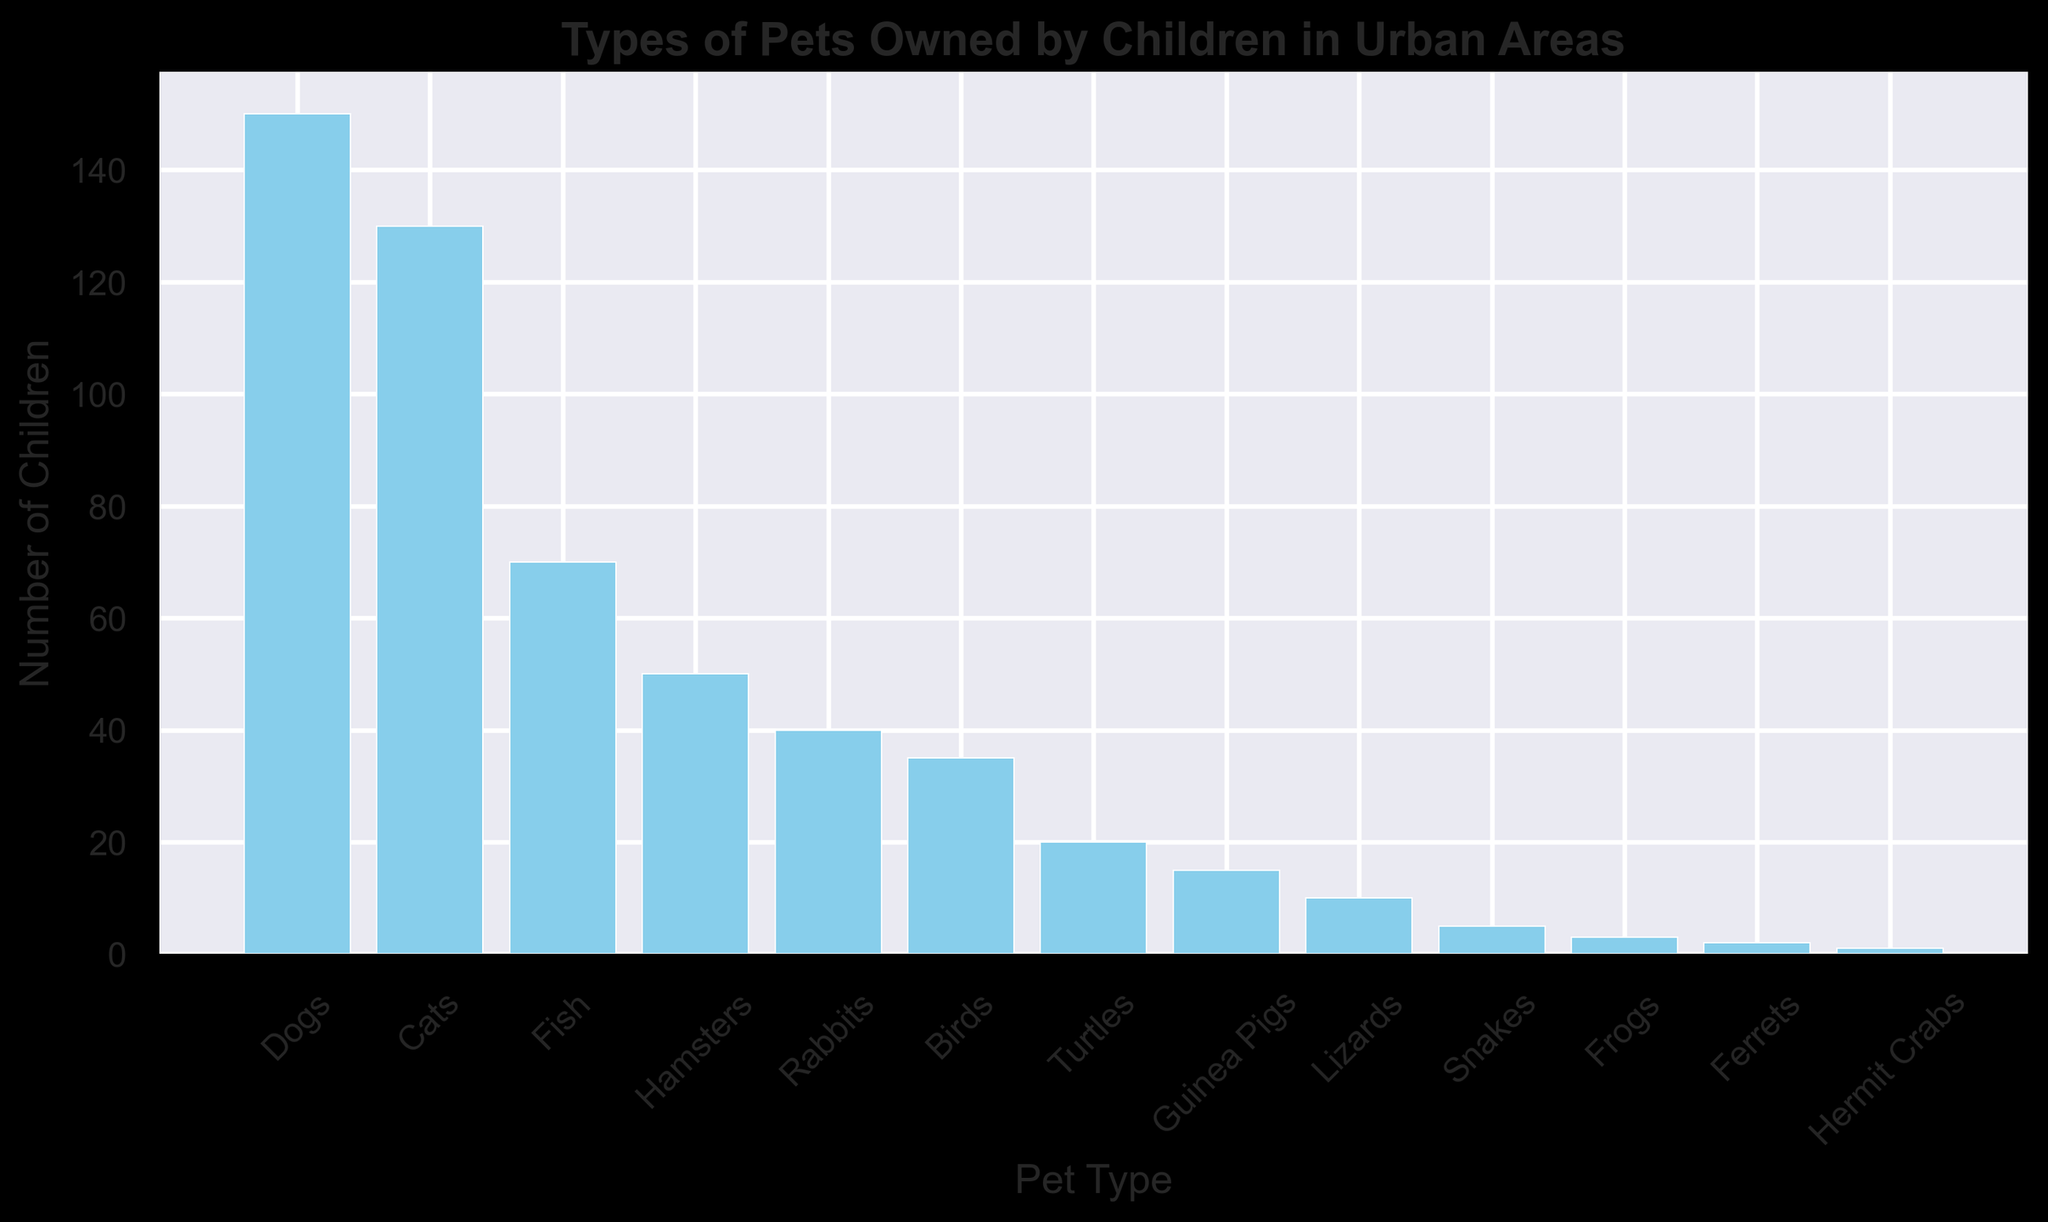How many more children own dogs than cats? To determine how many more children own dogs than cats, subtract the number of children who own cats from the number who own dogs: 150 (dogs) - 130 (cats) = 20
Answer: 20 Which pet type is owned by the fewest number of children? Identify the bar representing the lowest value on the chart. Hermit Crabs have the shortest bar, with only 1 child owning them.
Answer: Hermit Crabs What is the total number of children who own fish, hamsters, and rabbits combined? Add the number of children who own fish (70), hamsters (50), and rabbits (40): 70 + 50 + 40 = 160
Answer: 160 Are there more children who own birds or turtles? Compare the heights of the bars for birds (35) and turtles (20). Birds have a larger value.
Answer: Birds Which pet types are owned by fewer than 10 children? Look for bars with values less than 10. The relevant bars are: Lizards (10), Snakes (5), Frogs (3), Ferrets (2), Hermit Crabs (1).
Answer: Snakes, Frogs, Ferrets, Hermit Crabs How many children own either guinea pigs or lizards? Add the number of children who own guinea pigs (15) and lizards (10): 15 + 10 = 25
Answer: 25 What is the difference in the number of children owning the most common pet versus the least common pet? The most common pet is dogs (150 children), and the least common pet is Hermit Crabs (1 child). The difference is 150 - 1 = 149
Answer: 149 What is the second most commonly owned pet? Identify the second tallest bar after dogs. Cats, with 130 children, is the second most commonly owned pet.
Answer: Cats Do more children own rabbits or birds? Compare the bar heights for rabbits (40) and birds (35). Rabbits have a greater value.
Answer: Rabbits What is the total number of children who own pets mentioned in the chart? Sum all the values: 150 (dogs) + 130 (cats) + 70 (fish) + 50 (hamsters) + 40 (rabbits) + 35 (birds) + 20 (turtles) + 15 (guinea pigs) + 10 (lizards) + 5 (snakes) + 3 (frogs) + 2 (ferrets) + 1 (hermit crabs) = 526
Answer: 526 